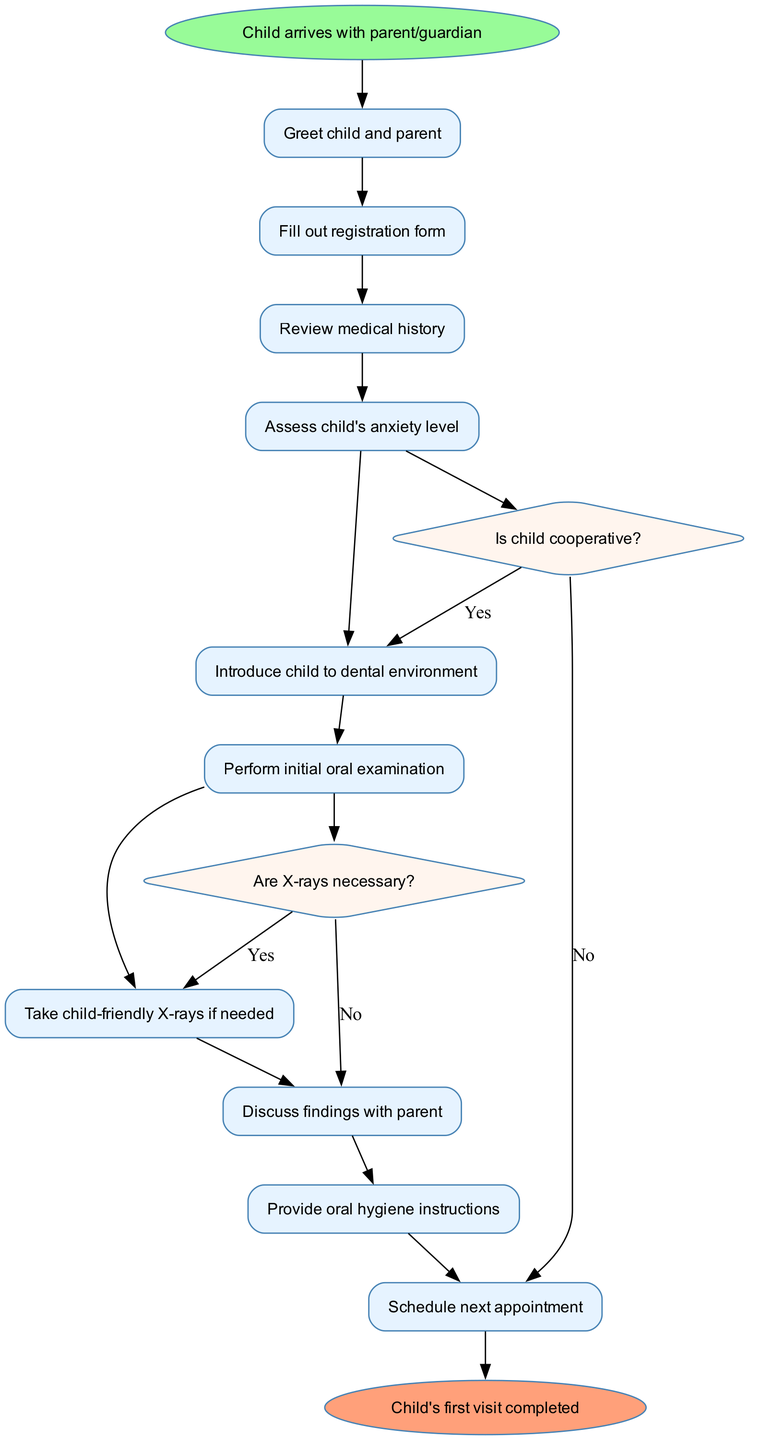What is the first activity in the process? The first activity listed in the diagram after the start node is "Greet child and parent". Since it's the first item in the activities section, it directly follows the start node.
Answer: Greet child and parent How many activities are there in total? By counting the items in the activities section, we can see there are ten activities stated in the list provided before the decisions.
Answer: 10 What is the decision following "Assess child's anxiety level"? The decision after the "Assess child's anxiety level" activity is "Is child cooperative?". This is directly indicated in the flow from that activity.
Answer: Is child cooperative? What happens if the child is not cooperative? If the child is not cooperative, the flow indicates to proceed to "Provide oral hygiene instructions". This is the outcome after the decision node "Is child cooperative?" labeled "No".
Answer: Provide oral hygiene instructions What indicates the end of the patient's first visit? The end of the patient's first visit is indicated by the node labeled "Child's first visit completed". It is the final outcome after all activities are processed.
Answer: Child's first visit completed How many decision points are present in the diagram? There are two decision points in the diagram as listed in the decisions section: "Is child cooperative?" and "Are X-rays necessary?". This accounts for the total number of decision nodes.
Answer: 2 What is the outcome if X-rays are not necessary? If X-rays are not necessary, the flow proceeds to "Discuss findings with parent" as indicated by the "Are X-rays necessary?" decision label "No".
Answer: Discuss findings with parent Which activity follows the "Perform initial oral examination"? Following the "Perform initial oral examination", the next activity in the sequence is contingent on the decision "Are X-rays necessary?". If the answer is "Yes", it goes to "Take child-friendly X-rays if needed".
Answer: Take child-friendly X-rays if needed What node does the process start with? The process starts with the node labeled "Child arrives with parent/guardian". This is the initial point indicated in the diagram.
Answer: Child arrives with parent/guardian 